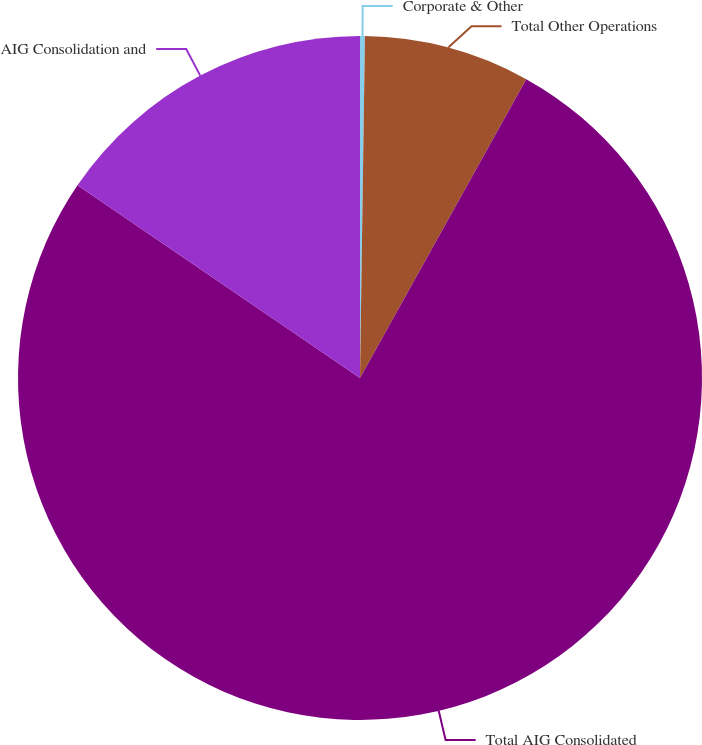Convert chart to OTSL. <chart><loc_0><loc_0><loc_500><loc_500><pie_chart><fcel>Corporate & Other<fcel>Total Other Operations<fcel>Total AIG Consolidated<fcel>AIG Consolidation and<nl><fcel>0.23%<fcel>7.85%<fcel>76.44%<fcel>15.47%<nl></chart> 